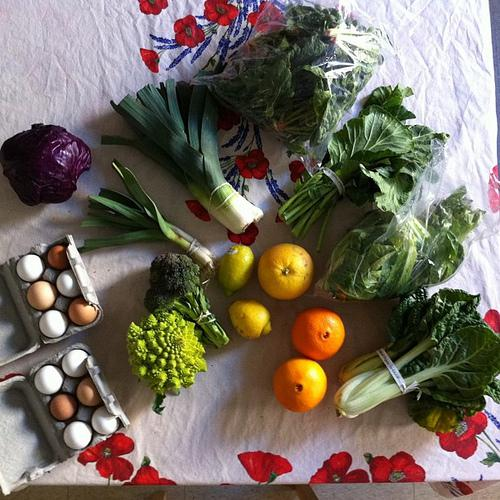Question: what color is the oranges?
Choices:
A. Yellow.
B. Gray.
C. White.
D. Orange.
Answer with the letter. Answer: D Question: what is in the cartons?
Choices:
A. Fish.
B. Cookies.
C. Eggs.
D. Donuts.
Answer with the letter. Answer: C Question: what color is the cabbage?
Choices:
A. Green.
B. Blue.
C. Brown.
D. Purple.
Answer with the letter. Answer: D Question: how many eggs are shown?
Choices:
A. 13.
B. 12.
C. 11.
D. 10.
Answer with the letter. Answer: B Question: how many eggs are in one carton?
Choices:
A. 12.
B. 6.
C. 8.
D. 4.
Answer with the letter. Answer: B Question: how many oranges are shown?
Choices:
A. 2.
B. 3.
C. 4.
D. 5.
Answer with the letter. Answer: A 